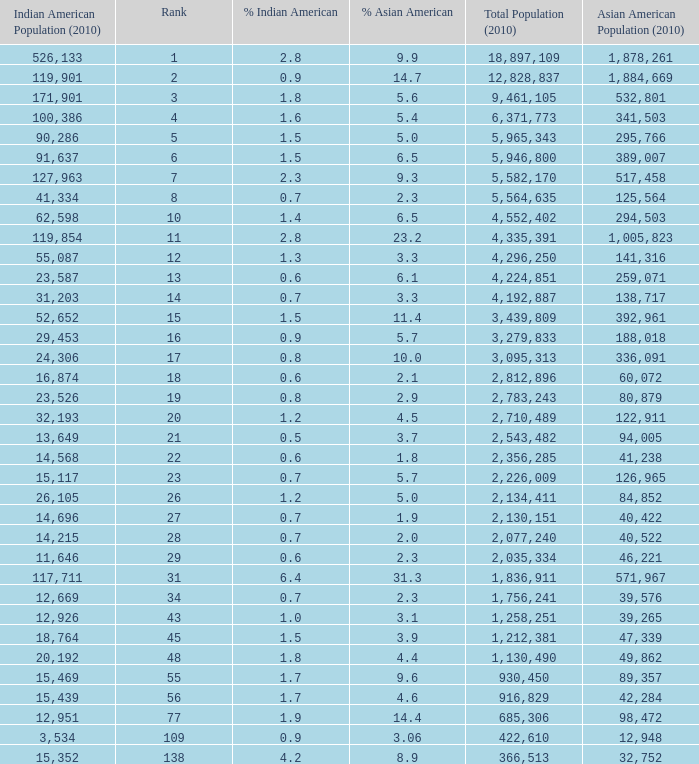What's the total population when there are 5.7% Asian American and fewer than 126,965 Asian American Population? None. 